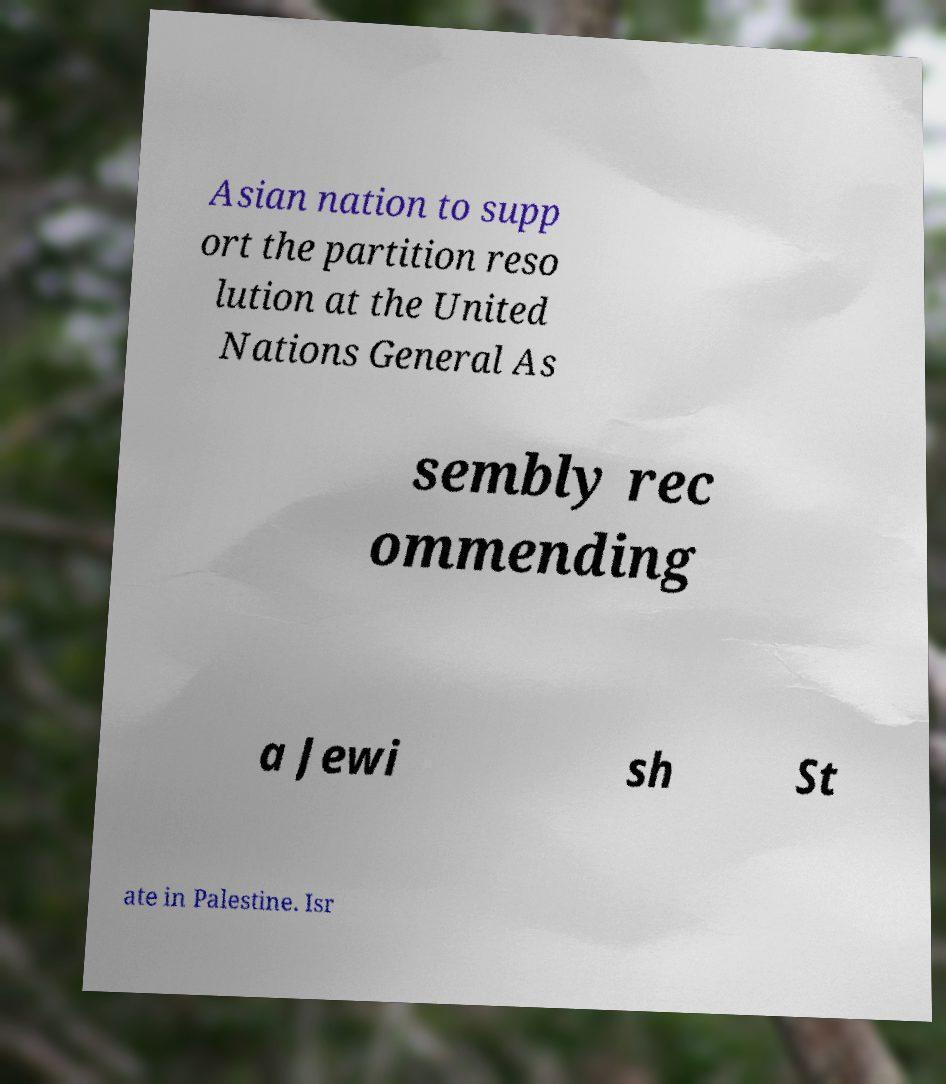Could you extract and type out the text from this image? Asian nation to supp ort the partition reso lution at the United Nations General As sembly rec ommending a Jewi sh St ate in Palestine. Isr 